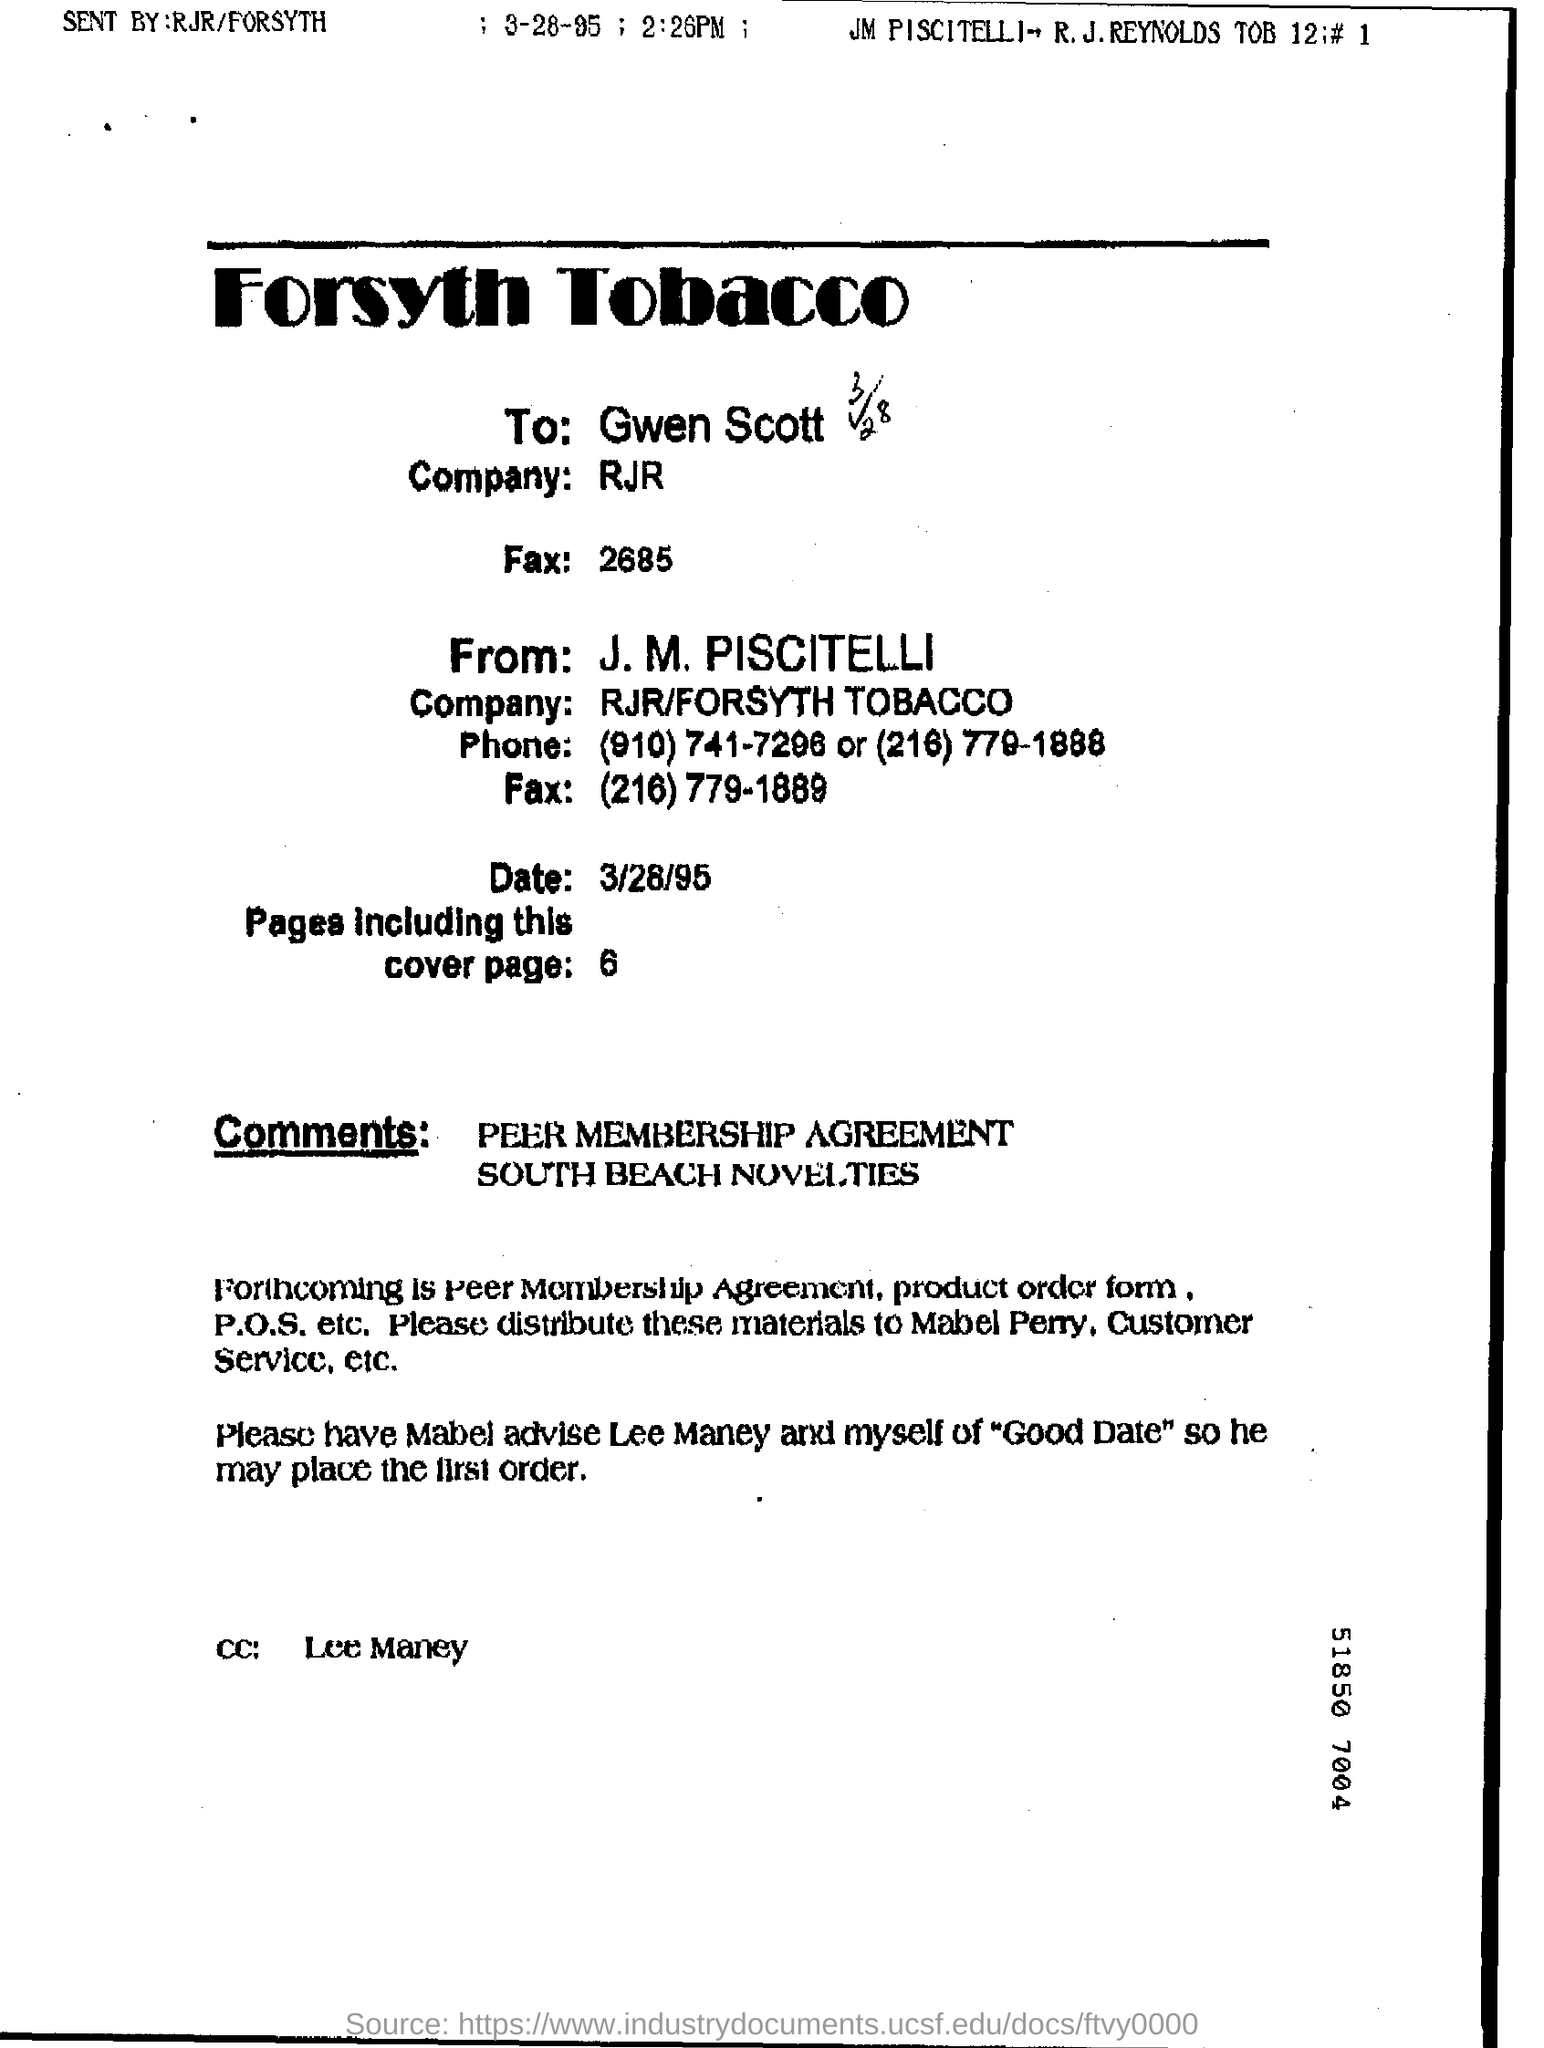To Whom is this letter addressed to?
Offer a terse response. Gwen Scott. 